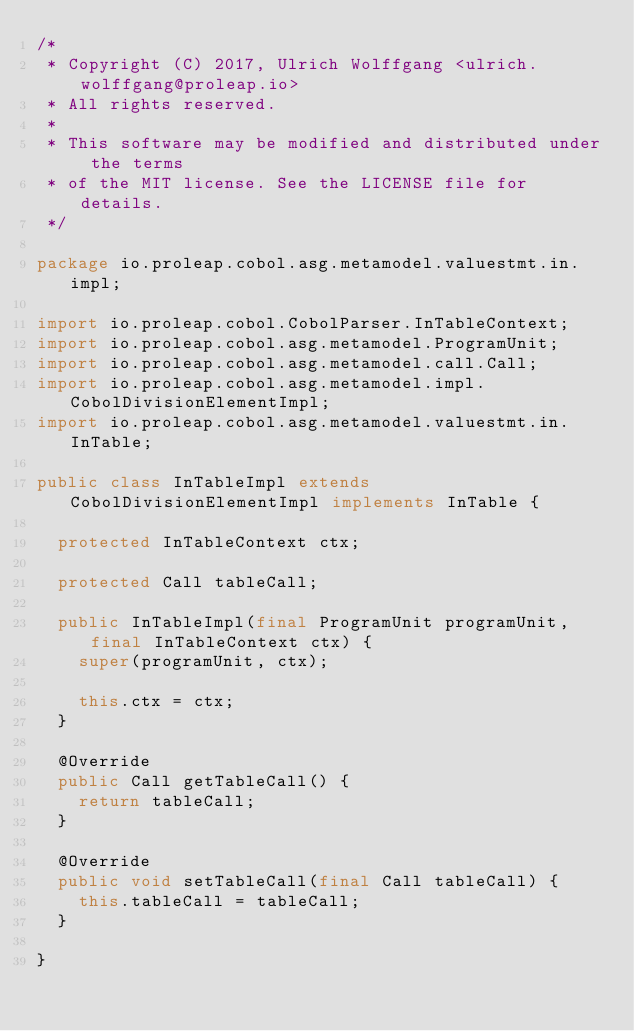Convert code to text. <code><loc_0><loc_0><loc_500><loc_500><_Java_>/*
 * Copyright (C) 2017, Ulrich Wolffgang <ulrich.wolffgang@proleap.io>
 * All rights reserved.
 *
 * This software may be modified and distributed under the terms
 * of the MIT license. See the LICENSE file for details.
 */

package io.proleap.cobol.asg.metamodel.valuestmt.in.impl;

import io.proleap.cobol.CobolParser.InTableContext;
import io.proleap.cobol.asg.metamodel.ProgramUnit;
import io.proleap.cobol.asg.metamodel.call.Call;
import io.proleap.cobol.asg.metamodel.impl.CobolDivisionElementImpl;
import io.proleap.cobol.asg.metamodel.valuestmt.in.InTable;

public class InTableImpl extends CobolDivisionElementImpl implements InTable {

	protected InTableContext ctx;

	protected Call tableCall;

	public InTableImpl(final ProgramUnit programUnit, final InTableContext ctx) {
		super(programUnit, ctx);

		this.ctx = ctx;
	}

	@Override
	public Call getTableCall() {
		return tableCall;
	}

	@Override
	public void setTableCall(final Call tableCall) {
		this.tableCall = tableCall;
	}

}
</code> 